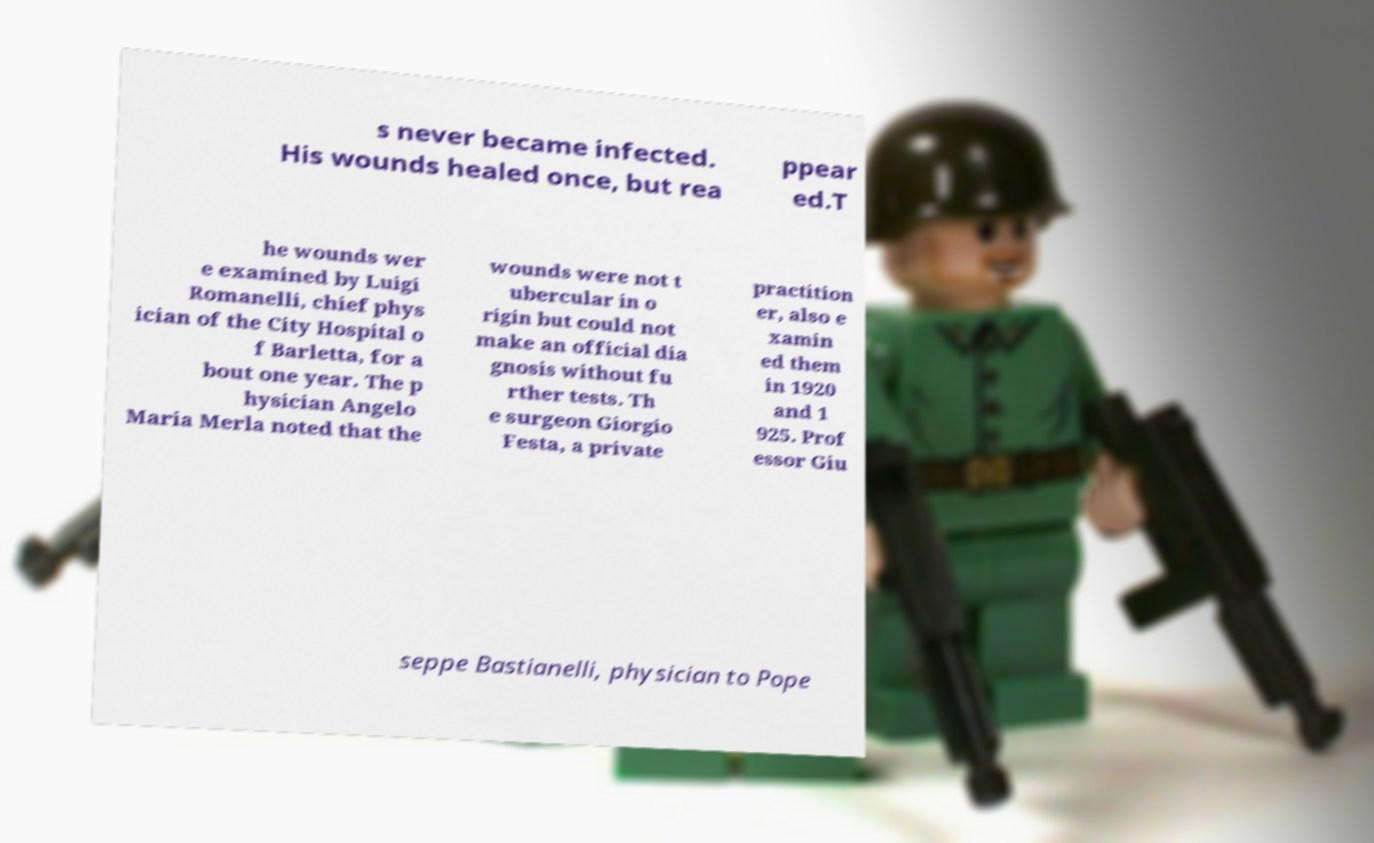Could you assist in decoding the text presented in this image and type it out clearly? s never became infected. His wounds healed once, but rea ppear ed.T he wounds wer e examined by Luigi Romanelli, chief phys ician of the City Hospital o f Barletta, for a bout one year. The p hysician Angelo Maria Merla noted that the wounds were not t ubercular in o rigin but could not make an official dia gnosis without fu rther tests. Th e surgeon Giorgio Festa, a private practition er, also e xamin ed them in 1920 and 1 925. Prof essor Giu seppe Bastianelli, physician to Pope 